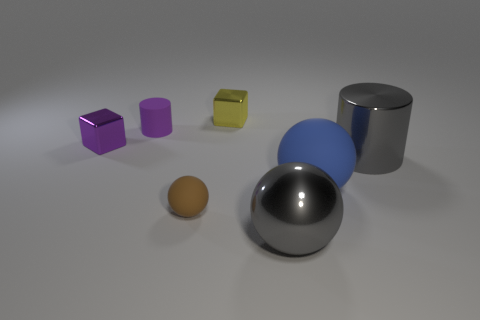What is the color of the other thing that is the same shape as the small yellow shiny object?
Your answer should be very brief. Purple. Does the small shiny object in front of the tiny cylinder have the same color as the tiny rubber cylinder?
Your response must be concise. Yes. Do the purple cylinder and the brown rubber sphere have the same size?
Provide a succinct answer. Yes. The tiny purple thing that is the same material as the large blue thing is what shape?
Your answer should be very brief. Cylinder. How many other things are the same shape as the brown thing?
Your answer should be very brief. 2. What shape is the gray thing in front of the large metal thing that is behind the large sphere in front of the large blue rubber ball?
Offer a very short reply. Sphere. How many blocks are either small yellow objects or brown things?
Provide a succinct answer. 1. Is there a small yellow metallic cube that is behind the small shiny thing on the right side of the purple metal block?
Ensure brevity in your answer.  No. There is a yellow thing; does it have the same shape as the tiny metallic thing that is on the left side of the tiny brown rubber thing?
Offer a terse response. Yes. What number of other things are there of the same size as the purple rubber object?
Ensure brevity in your answer.  3. 